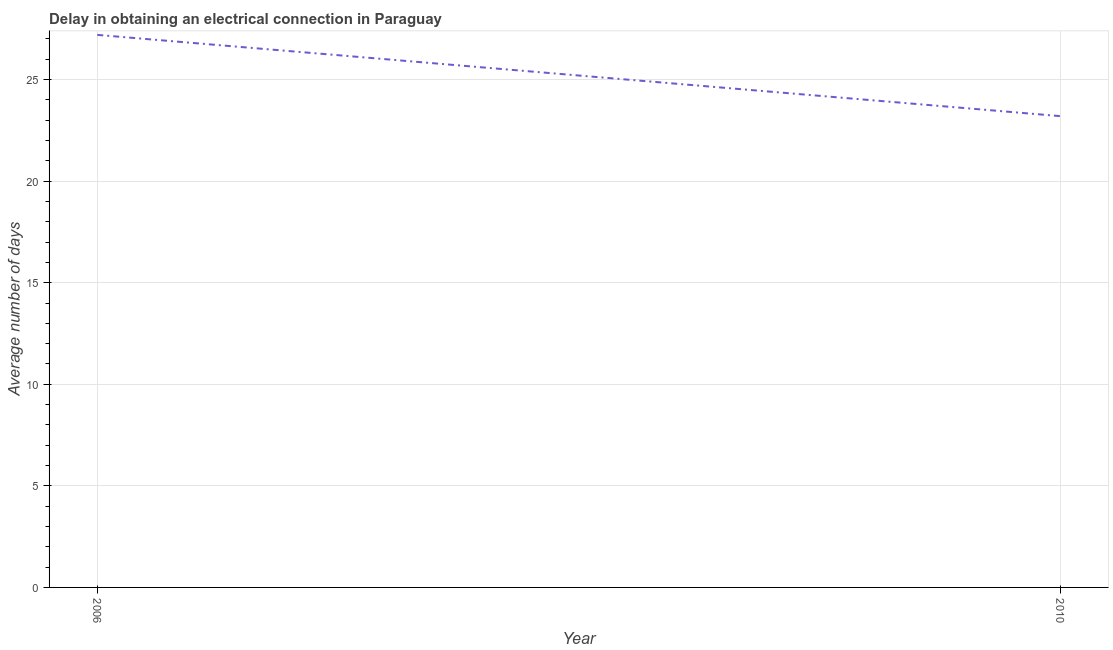What is the dalay in electrical connection in 2010?
Your answer should be compact. 23.2. Across all years, what is the maximum dalay in electrical connection?
Ensure brevity in your answer.  27.2. Across all years, what is the minimum dalay in electrical connection?
Offer a terse response. 23.2. In which year was the dalay in electrical connection minimum?
Make the answer very short. 2010. What is the sum of the dalay in electrical connection?
Provide a short and direct response. 50.4. What is the difference between the dalay in electrical connection in 2006 and 2010?
Provide a succinct answer. 4. What is the average dalay in electrical connection per year?
Keep it short and to the point. 25.2. What is the median dalay in electrical connection?
Offer a terse response. 25.2. Do a majority of the years between 2010 and 2006 (inclusive) have dalay in electrical connection greater than 25 days?
Give a very brief answer. No. What is the ratio of the dalay in electrical connection in 2006 to that in 2010?
Your answer should be very brief. 1.17. Is the dalay in electrical connection in 2006 less than that in 2010?
Give a very brief answer. No. How many lines are there?
Your answer should be very brief. 1. Does the graph contain any zero values?
Provide a short and direct response. No. Does the graph contain grids?
Offer a terse response. Yes. What is the title of the graph?
Your answer should be very brief. Delay in obtaining an electrical connection in Paraguay. What is the label or title of the X-axis?
Your answer should be very brief. Year. What is the label or title of the Y-axis?
Offer a terse response. Average number of days. What is the Average number of days in 2006?
Keep it short and to the point. 27.2. What is the Average number of days of 2010?
Make the answer very short. 23.2. What is the difference between the Average number of days in 2006 and 2010?
Give a very brief answer. 4. What is the ratio of the Average number of days in 2006 to that in 2010?
Offer a very short reply. 1.17. 